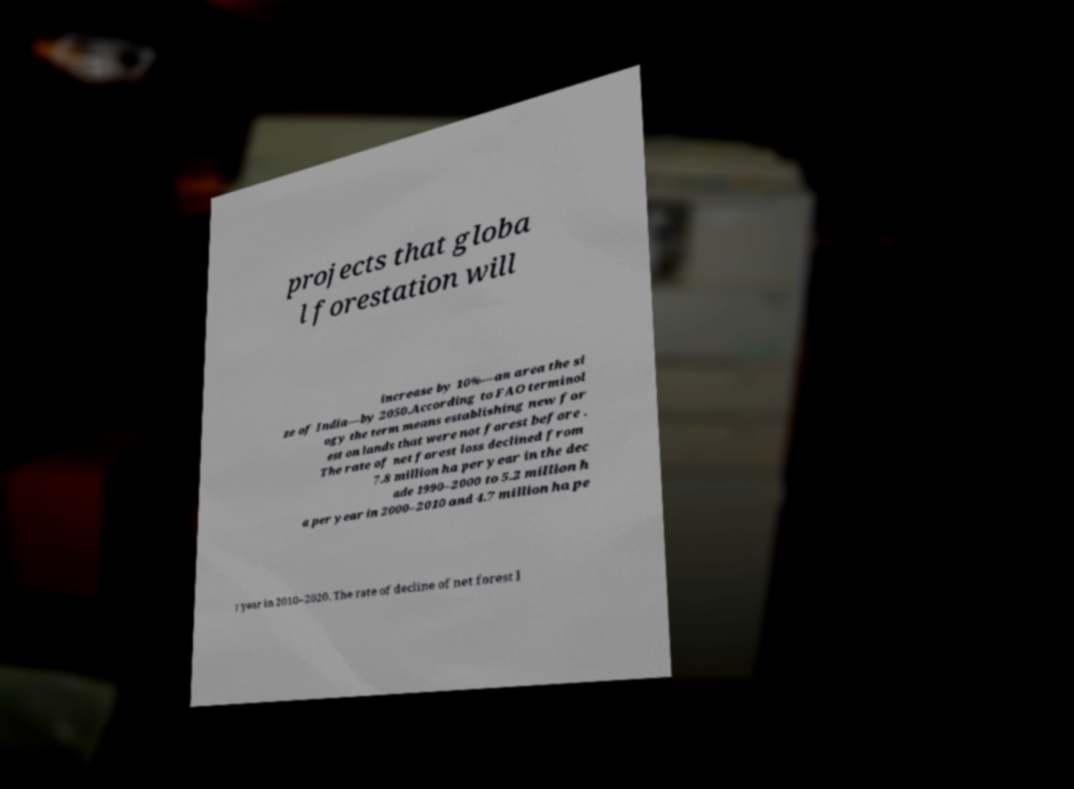Could you extract and type out the text from this image? projects that globa l forestation will increase by 10%—an area the si ze of India—by 2050.According to FAO terminol ogy the term means establishing new for est on lands that were not forest before . The rate of net forest loss declined from 7.8 million ha per year in the dec ade 1990–2000 to 5.2 million h a per year in 2000–2010 and 4.7 million ha pe r year in 2010–2020. The rate of decline of net forest l 